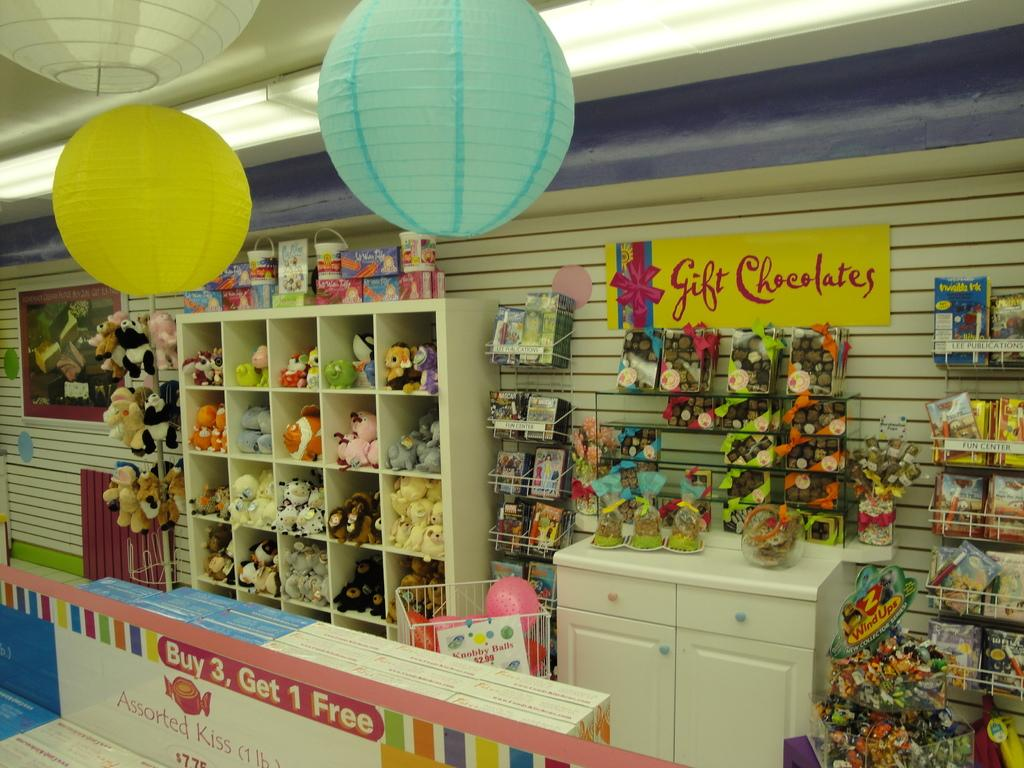<image>
Provide a brief description of the given image. a gift store with lots of products and a sign reading 'gift chocolates' 